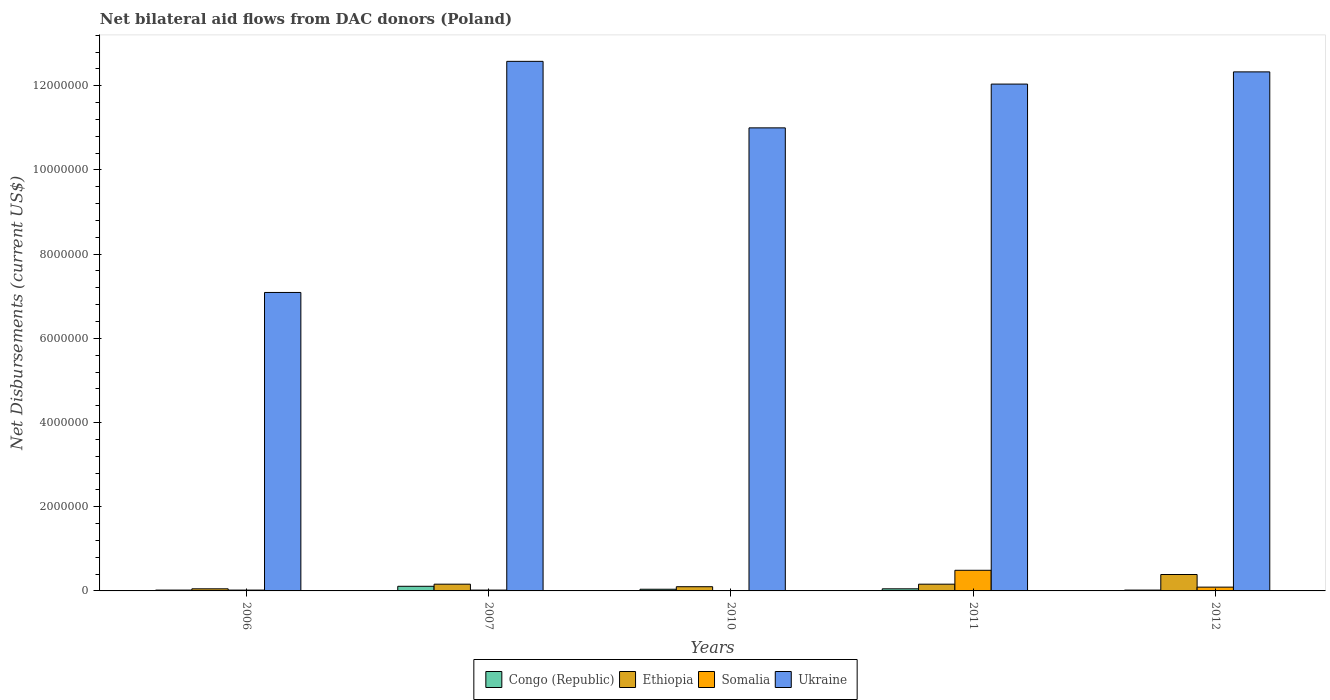How many different coloured bars are there?
Your answer should be very brief. 4. How many groups of bars are there?
Your answer should be very brief. 5. Are the number of bars per tick equal to the number of legend labels?
Keep it short and to the point. Yes. How many bars are there on the 1st tick from the left?
Give a very brief answer. 4. How many bars are there on the 3rd tick from the right?
Provide a short and direct response. 4. What is the label of the 3rd group of bars from the left?
Your answer should be compact. 2010. In how many cases, is the number of bars for a given year not equal to the number of legend labels?
Your response must be concise. 0. What is the net bilateral aid flows in Ethiopia in 2007?
Provide a succinct answer. 1.60e+05. Across all years, what is the maximum net bilateral aid flows in Ethiopia?
Your response must be concise. 3.90e+05. Across all years, what is the minimum net bilateral aid flows in Ethiopia?
Your answer should be very brief. 5.00e+04. In which year was the net bilateral aid flows in Ethiopia minimum?
Your answer should be very brief. 2006. What is the total net bilateral aid flows in Somalia in the graph?
Offer a terse response. 6.30e+05. What is the difference between the net bilateral aid flows in Ukraine in 2010 and the net bilateral aid flows in Congo (Republic) in 2012?
Offer a very short reply. 1.10e+07. What is the average net bilateral aid flows in Somalia per year?
Keep it short and to the point. 1.26e+05. In how many years, is the net bilateral aid flows in Congo (Republic) greater than 7200000 US$?
Your answer should be compact. 0. What is the ratio of the net bilateral aid flows in Congo (Republic) in 2007 to that in 2011?
Ensure brevity in your answer.  2.2. What is the difference between the highest and the lowest net bilateral aid flows in Ethiopia?
Your answer should be very brief. 3.40e+05. What does the 4th bar from the left in 2011 represents?
Your answer should be compact. Ukraine. What does the 1st bar from the right in 2006 represents?
Keep it short and to the point. Ukraine. Is it the case that in every year, the sum of the net bilateral aid flows in Somalia and net bilateral aid flows in Congo (Republic) is greater than the net bilateral aid flows in Ukraine?
Offer a terse response. No. How many bars are there?
Your answer should be very brief. 20. How many years are there in the graph?
Provide a short and direct response. 5. Where does the legend appear in the graph?
Offer a very short reply. Bottom center. What is the title of the graph?
Make the answer very short. Net bilateral aid flows from DAC donors (Poland). What is the label or title of the Y-axis?
Offer a very short reply. Net Disbursements (current US$). What is the Net Disbursements (current US$) in Ethiopia in 2006?
Your response must be concise. 5.00e+04. What is the Net Disbursements (current US$) in Somalia in 2006?
Provide a succinct answer. 2.00e+04. What is the Net Disbursements (current US$) of Ukraine in 2006?
Your response must be concise. 7.09e+06. What is the Net Disbursements (current US$) of Congo (Republic) in 2007?
Keep it short and to the point. 1.10e+05. What is the Net Disbursements (current US$) in Ethiopia in 2007?
Provide a short and direct response. 1.60e+05. What is the Net Disbursements (current US$) in Somalia in 2007?
Your answer should be very brief. 2.00e+04. What is the Net Disbursements (current US$) of Ukraine in 2007?
Your response must be concise. 1.26e+07. What is the Net Disbursements (current US$) in Somalia in 2010?
Keep it short and to the point. 10000. What is the Net Disbursements (current US$) in Ukraine in 2010?
Offer a very short reply. 1.10e+07. What is the Net Disbursements (current US$) of Somalia in 2011?
Your answer should be compact. 4.90e+05. What is the Net Disbursements (current US$) in Ukraine in 2011?
Offer a very short reply. 1.20e+07. What is the Net Disbursements (current US$) of Ukraine in 2012?
Your response must be concise. 1.23e+07. Across all years, what is the maximum Net Disbursements (current US$) of Ukraine?
Your answer should be very brief. 1.26e+07. Across all years, what is the minimum Net Disbursements (current US$) in Congo (Republic)?
Your response must be concise. 2.00e+04. Across all years, what is the minimum Net Disbursements (current US$) in Ethiopia?
Offer a very short reply. 5.00e+04. Across all years, what is the minimum Net Disbursements (current US$) of Somalia?
Provide a short and direct response. 10000. Across all years, what is the minimum Net Disbursements (current US$) of Ukraine?
Your answer should be very brief. 7.09e+06. What is the total Net Disbursements (current US$) of Congo (Republic) in the graph?
Offer a very short reply. 2.40e+05. What is the total Net Disbursements (current US$) of Ethiopia in the graph?
Give a very brief answer. 8.60e+05. What is the total Net Disbursements (current US$) of Somalia in the graph?
Ensure brevity in your answer.  6.30e+05. What is the total Net Disbursements (current US$) of Ukraine in the graph?
Keep it short and to the point. 5.50e+07. What is the difference between the Net Disbursements (current US$) in Congo (Republic) in 2006 and that in 2007?
Make the answer very short. -9.00e+04. What is the difference between the Net Disbursements (current US$) of Ethiopia in 2006 and that in 2007?
Your answer should be compact. -1.10e+05. What is the difference between the Net Disbursements (current US$) of Ukraine in 2006 and that in 2007?
Give a very brief answer. -5.49e+06. What is the difference between the Net Disbursements (current US$) in Ukraine in 2006 and that in 2010?
Your answer should be compact. -3.91e+06. What is the difference between the Net Disbursements (current US$) in Congo (Republic) in 2006 and that in 2011?
Keep it short and to the point. -3.00e+04. What is the difference between the Net Disbursements (current US$) of Ethiopia in 2006 and that in 2011?
Your answer should be very brief. -1.10e+05. What is the difference between the Net Disbursements (current US$) of Somalia in 2006 and that in 2011?
Make the answer very short. -4.70e+05. What is the difference between the Net Disbursements (current US$) in Ukraine in 2006 and that in 2011?
Provide a succinct answer. -4.95e+06. What is the difference between the Net Disbursements (current US$) of Ethiopia in 2006 and that in 2012?
Provide a succinct answer. -3.40e+05. What is the difference between the Net Disbursements (current US$) of Ukraine in 2006 and that in 2012?
Your response must be concise. -5.24e+06. What is the difference between the Net Disbursements (current US$) of Congo (Republic) in 2007 and that in 2010?
Your response must be concise. 7.00e+04. What is the difference between the Net Disbursements (current US$) of Ethiopia in 2007 and that in 2010?
Ensure brevity in your answer.  6.00e+04. What is the difference between the Net Disbursements (current US$) in Somalia in 2007 and that in 2010?
Your answer should be compact. 10000. What is the difference between the Net Disbursements (current US$) in Ukraine in 2007 and that in 2010?
Offer a terse response. 1.58e+06. What is the difference between the Net Disbursements (current US$) of Ethiopia in 2007 and that in 2011?
Your response must be concise. 0. What is the difference between the Net Disbursements (current US$) of Somalia in 2007 and that in 2011?
Ensure brevity in your answer.  -4.70e+05. What is the difference between the Net Disbursements (current US$) of Ukraine in 2007 and that in 2011?
Ensure brevity in your answer.  5.40e+05. What is the difference between the Net Disbursements (current US$) in Congo (Republic) in 2007 and that in 2012?
Give a very brief answer. 9.00e+04. What is the difference between the Net Disbursements (current US$) in Somalia in 2007 and that in 2012?
Your response must be concise. -7.00e+04. What is the difference between the Net Disbursements (current US$) in Ethiopia in 2010 and that in 2011?
Give a very brief answer. -6.00e+04. What is the difference between the Net Disbursements (current US$) in Somalia in 2010 and that in 2011?
Keep it short and to the point. -4.80e+05. What is the difference between the Net Disbursements (current US$) in Ukraine in 2010 and that in 2011?
Ensure brevity in your answer.  -1.04e+06. What is the difference between the Net Disbursements (current US$) in Congo (Republic) in 2010 and that in 2012?
Ensure brevity in your answer.  2.00e+04. What is the difference between the Net Disbursements (current US$) of Somalia in 2010 and that in 2012?
Your answer should be very brief. -8.00e+04. What is the difference between the Net Disbursements (current US$) of Ukraine in 2010 and that in 2012?
Make the answer very short. -1.33e+06. What is the difference between the Net Disbursements (current US$) in Ethiopia in 2011 and that in 2012?
Keep it short and to the point. -2.30e+05. What is the difference between the Net Disbursements (current US$) in Ukraine in 2011 and that in 2012?
Your answer should be very brief. -2.90e+05. What is the difference between the Net Disbursements (current US$) in Congo (Republic) in 2006 and the Net Disbursements (current US$) in Ethiopia in 2007?
Your response must be concise. -1.40e+05. What is the difference between the Net Disbursements (current US$) of Congo (Republic) in 2006 and the Net Disbursements (current US$) of Ukraine in 2007?
Make the answer very short. -1.26e+07. What is the difference between the Net Disbursements (current US$) of Ethiopia in 2006 and the Net Disbursements (current US$) of Somalia in 2007?
Provide a short and direct response. 3.00e+04. What is the difference between the Net Disbursements (current US$) in Ethiopia in 2006 and the Net Disbursements (current US$) in Ukraine in 2007?
Your answer should be compact. -1.25e+07. What is the difference between the Net Disbursements (current US$) in Somalia in 2006 and the Net Disbursements (current US$) in Ukraine in 2007?
Your response must be concise. -1.26e+07. What is the difference between the Net Disbursements (current US$) in Congo (Republic) in 2006 and the Net Disbursements (current US$) in Ethiopia in 2010?
Offer a terse response. -8.00e+04. What is the difference between the Net Disbursements (current US$) in Congo (Republic) in 2006 and the Net Disbursements (current US$) in Somalia in 2010?
Make the answer very short. 10000. What is the difference between the Net Disbursements (current US$) in Congo (Republic) in 2006 and the Net Disbursements (current US$) in Ukraine in 2010?
Your answer should be very brief. -1.10e+07. What is the difference between the Net Disbursements (current US$) of Ethiopia in 2006 and the Net Disbursements (current US$) of Ukraine in 2010?
Provide a succinct answer. -1.10e+07. What is the difference between the Net Disbursements (current US$) in Somalia in 2006 and the Net Disbursements (current US$) in Ukraine in 2010?
Your response must be concise. -1.10e+07. What is the difference between the Net Disbursements (current US$) in Congo (Republic) in 2006 and the Net Disbursements (current US$) in Somalia in 2011?
Ensure brevity in your answer.  -4.70e+05. What is the difference between the Net Disbursements (current US$) of Congo (Republic) in 2006 and the Net Disbursements (current US$) of Ukraine in 2011?
Keep it short and to the point. -1.20e+07. What is the difference between the Net Disbursements (current US$) in Ethiopia in 2006 and the Net Disbursements (current US$) in Somalia in 2011?
Provide a succinct answer. -4.40e+05. What is the difference between the Net Disbursements (current US$) in Ethiopia in 2006 and the Net Disbursements (current US$) in Ukraine in 2011?
Give a very brief answer. -1.20e+07. What is the difference between the Net Disbursements (current US$) in Somalia in 2006 and the Net Disbursements (current US$) in Ukraine in 2011?
Provide a succinct answer. -1.20e+07. What is the difference between the Net Disbursements (current US$) of Congo (Republic) in 2006 and the Net Disbursements (current US$) of Ethiopia in 2012?
Keep it short and to the point. -3.70e+05. What is the difference between the Net Disbursements (current US$) of Congo (Republic) in 2006 and the Net Disbursements (current US$) of Ukraine in 2012?
Offer a terse response. -1.23e+07. What is the difference between the Net Disbursements (current US$) in Ethiopia in 2006 and the Net Disbursements (current US$) in Ukraine in 2012?
Offer a very short reply. -1.23e+07. What is the difference between the Net Disbursements (current US$) in Somalia in 2006 and the Net Disbursements (current US$) in Ukraine in 2012?
Offer a terse response. -1.23e+07. What is the difference between the Net Disbursements (current US$) in Congo (Republic) in 2007 and the Net Disbursements (current US$) in Somalia in 2010?
Give a very brief answer. 1.00e+05. What is the difference between the Net Disbursements (current US$) in Congo (Republic) in 2007 and the Net Disbursements (current US$) in Ukraine in 2010?
Ensure brevity in your answer.  -1.09e+07. What is the difference between the Net Disbursements (current US$) of Ethiopia in 2007 and the Net Disbursements (current US$) of Ukraine in 2010?
Provide a succinct answer. -1.08e+07. What is the difference between the Net Disbursements (current US$) in Somalia in 2007 and the Net Disbursements (current US$) in Ukraine in 2010?
Provide a succinct answer. -1.10e+07. What is the difference between the Net Disbursements (current US$) of Congo (Republic) in 2007 and the Net Disbursements (current US$) of Ethiopia in 2011?
Your answer should be compact. -5.00e+04. What is the difference between the Net Disbursements (current US$) in Congo (Republic) in 2007 and the Net Disbursements (current US$) in Somalia in 2011?
Give a very brief answer. -3.80e+05. What is the difference between the Net Disbursements (current US$) of Congo (Republic) in 2007 and the Net Disbursements (current US$) of Ukraine in 2011?
Your response must be concise. -1.19e+07. What is the difference between the Net Disbursements (current US$) of Ethiopia in 2007 and the Net Disbursements (current US$) of Somalia in 2011?
Your answer should be compact. -3.30e+05. What is the difference between the Net Disbursements (current US$) in Ethiopia in 2007 and the Net Disbursements (current US$) in Ukraine in 2011?
Give a very brief answer. -1.19e+07. What is the difference between the Net Disbursements (current US$) in Somalia in 2007 and the Net Disbursements (current US$) in Ukraine in 2011?
Your answer should be very brief. -1.20e+07. What is the difference between the Net Disbursements (current US$) in Congo (Republic) in 2007 and the Net Disbursements (current US$) in Ethiopia in 2012?
Your response must be concise. -2.80e+05. What is the difference between the Net Disbursements (current US$) of Congo (Republic) in 2007 and the Net Disbursements (current US$) of Somalia in 2012?
Ensure brevity in your answer.  2.00e+04. What is the difference between the Net Disbursements (current US$) of Congo (Republic) in 2007 and the Net Disbursements (current US$) of Ukraine in 2012?
Your answer should be compact. -1.22e+07. What is the difference between the Net Disbursements (current US$) of Ethiopia in 2007 and the Net Disbursements (current US$) of Ukraine in 2012?
Your answer should be very brief. -1.22e+07. What is the difference between the Net Disbursements (current US$) in Somalia in 2007 and the Net Disbursements (current US$) in Ukraine in 2012?
Ensure brevity in your answer.  -1.23e+07. What is the difference between the Net Disbursements (current US$) in Congo (Republic) in 2010 and the Net Disbursements (current US$) in Somalia in 2011?
Keep it short and to the point. -4.50e+05. What is the difference between the Net Disbursements (current US$) of Congo (Republic) in 2010 and the Net Disbursements (current US$) of Ukraine in 2011?
Make the answer very short. -1.20e+07. What is the difference between the Net Disbursements (current US$) of Ethiopia in 2010 and the Net Disbursements (current US$) of Somalia in 2011?
Provide a succinct answer. -3.90e+05. What is the difference between the Net Disbursements (current US$) of Ethiopia in 2010 and the Net Disbursements (current US$) of Ukraine in 2011?
Make the answer very short. -1.19e+07. What is the difference between the Net Disbursements (current US$) of Somalia in 2010 and the Net Disbursements (current US$) of Ukraine in 2011?
Your answer should be very brief. -1.20e+07. What is the difference between the Net Disbursements (current US$) of Congo (Republic) in 2010 and the Net Disbursements (current US$) of Ethiopia in 2012?
Give a very brief answer. -3.50e+05. What is the difference between the Net Disbursements (current US$) in Congo (Republic) in 2010 and the Net Disbursements (current US$) in Somalia in 2012?
Your answer should be very brief. -5.00e+04. What is the difference between the Net Disbursements (current US$) of Congo (Republic) in 2010 and the Net Disbursements (current US$) of Ukraine in 2012?
Your answer should be compact. -1.23e+07. What is the difference between the Net Disbursements (current US$) in Ethiopia in 2010 and the Net Disbursements (current US$) in Ukraine in 2012?
Your answer should be very brief. -1.22e+07. What is the difference between the Net Disbursements (current US$) in Somalia in 2010 and the Net Disbursements (current US$) in Ukraine in 2012?
Keep it short and to the point. -1.23e+07. What is the difference between the Net Disbursements (current US$) of Congo (Republic) in 2011 and the Net Disbursements (current US$) of Somalia in 2012?
Your answer should be very brief. -4.00e+04. What is the difference between the Net Disbursements (current US$) of Congo (Republic) in 2011 and the Net Disbursements (current US$) of Ukraine in 2012?
Give a very brief answer. -1.23e+07. What is the difference between the Net Disbursements (current US$) in Ethiopia in 2011 and the Net Disbursements (current US$) in Ukraine in 2012?
Your answer should be very brief. -1.22e+07. What is the difference between the Net Disbursements (current US$) in Somalia in 2011 and the Net Disbursements (current US$) in Ukraine in 2012?
Keep it short and to the point. -1.18e+07. What is the average Net Disbursements (current US$) of Congo (Republic) per year?
Ensure brevity in your answer.  4.80e+04. What is the average Net Disbursements (current US$) in Ethiopia per year?
Offer a very short reply. 1.72e+05. What is the average Net Disbursements (current US$) in Somalia per year?
Offer a very short reply. 1.26e+05. What is the average Net Disbursements (current US$) in Ukraine per year?
Keep it short and to the point. 1.10e+07. In the year 2006, what is the difference between the Net Disbursements (current US$) of Congo (Republic) and Net Disbursements (current US$) of Ethiopia?
Ensure brevity in your answer.  -3.00e+04. In the year 2006, what is the difference between the Net Disbursements (current US$) in Congo (Republic) and Net Disbursements (current US$) in Somalia?
Your answer should be compact. 0. In the year 2006, what is the difference between the Net Disbursements (current US$) in Congo (Republic) and Net Disbursements (current US$) in Ukraine?
Make the answer very short. -7.07e+06. In the year 2006, what is the difference between the Net Disbursements (current US$) in Ethiopia and Net Disbursements (current US$) in Ukraine?
Give a very brief answer. -7.04e+06. In the year 2006, what is the difference between the Net Disbursements (current US$) of Somalia and Net Disbursements (current US$) of Ukraine?
Provide a short and direct response. -7.07e+06. In the year 2007, what is the difference between the Net Disbursements (current US$) in Congo (Republic) and Net Disbursements (current US$) in Ethiopia?
Your answer should be very brief. -5.00e+04. In the year 2007, what is the difference between the Net Disbursements (current US$) of Congo (Republic) and Net Disbursements (current US$) of Somalia?
Provide a short and direct response. 9.00e+04. In the year 2007, what is the difference between the Net Disbursements (current US$) of Congo (Republic) and Net Disbursements (current US$) of Ukraine?
Your response must be concise. -1.25e+07. In the year 2007, what is the difference between the Net Disbursements (current US$) in Ethiopia and Net Disbursements (current US$) in Somalia?
Your response must be concise. 1.40e+05. In the year 2007, what is the difference between the Net Disbursements (current US$) of Ethiopia and Net Disbursements (current US$) of Ukraine?
Offer a terse response. -1.24e+07. In the year 2007, what is the difference between the Net Disbursements (current US$) of Somalia and Net Disbursements (current US$) of Ukraine?
Make the answer very short. -1.26e+07. In the year 2010, what is the difference between the Net Disbursements (current US$) in Congo (Republic) and Net Disbursements (current US$) in Somalia?
Give a very brief answer. 3.00e+04. In the year 2010, what is the difference between the Net Disbursements (current US$) of Congo (Republic) and Net Disbursements (current US$) of Ukraine?
Make the answer very short. -1.10e+07. In the year 2010, what is the difference between the Net Disbursements (current US$) in Ethiopia and Net Disbursements (current US$) in Somalia?
Your answer should be compact. 9.00e+04. In the year 2010, what is the difference between the Net Disbursements (current US$) of Ethiopia and Net Disbursements (current US$) of Ukraine?
Provide a short and direct response. -1.09e+07. In the year 2010, what is the difference between the Net Disbursements (current US$) in Somalia and Net Disbursements (current US$) in Ukraine?
Your answer should be very brief. -1.10e+07. In the year 2011, what is the difference between the Net Disbursements (current US$) in Congo (Republic) and Net Disbursements (current US$) in Somalia?
Your answer should be compact. -4.40e+05. In the year 2011, what is the difference between the Net Disbursements (current US$) in Congo (Republic) and Net Disbursements (current US$) in Ukraine?
Your answer should be compact. -1.20e+07. In the year 2011, what is the difference between the Net Disbursements (current US$) of Ethiopia and Net Disbursements (current US$) of Somalia?
Your answer should be compact. -3.30e+05. In the year 2011, what is the difference between the Net Disbursements (current US$) in Ethiopia and Net Disbursements (current US$) in Ukraine?
Give a very brief answer. -1.19e+07. In the year 2011, what is the difference between the Net Disbursements (current US$) of Somalia and Net Disbursements (current US$) of Ukraine?
Your answer should be compact. -1.16e+07. In the year 2012, what is the difference between the Net Disbursements (current US$) of Congo (Republic) and Net Disbursements (current US$) of Ethiopia?
Offer a terse response. -3.70e+05. In the year 2012, what is the difference between the Net Disbursements (current US$) in Congo (Republic) and Net Disbursements (current US$) in Somalia?
Your answer should be very brief. -7.00e+04. In the year 2012, what is the difference between the Net Disbursements (current US$) in Congo (Republic) and Net Disbursements (current US$) in Ukraine?
Provide a short and direct response. -1.23e+07. In the year 2012, what is the difference between the Net Disbursements (current US$) in Ethiopia and Net Disbursements (current US$) in Ukraine?
Make the answer very short. -1.19e+07. In the year 2012, what is the difference between the Net Disbursements (current US$) of Somalia and Net Disbursements (current US$) of Ukraine?
Give a very brief answer. -1.22e+07. What is the ratio of the Net Disbursements (current US$) of Congo (Republic) in 2006 to that in 2007?
Offer a terse response. 0.18. What is the ratio of the Net Disbursements (current US$) in Ethiopia in 2006 to that in 2007?
Provide a short and direct response. 0.31. What is the ratio of the Net Disbursements (current US$) in Ukraine in 2006 to that in 2007?
Offer a terse response. 0.56. What is the ratio of the Net Disbursements (current US$) of Ethiopia in 2006 to that in 2010?
Your answer should be compact. 0.5. What is the ratio of the Net Disbursements (current US$) of Somalia in 2006 to that in 2010?
Offer a very short reply. 2. What is the ratio of the Net Disbursements (current US$) in Ukraine in 2006 to that in 2010?
Your answer should be compact. 0.64. What is the ratio of the Net Disbursements (current US$) in Congo (Republic) in 2006 to that in 2011?
Give a very brief answer. 0.4. What is the ratio of the Net Disbursements (current US$) of Ethiopia in 2006 to that in 2011?
Make the answer very short. 0.31. What is the ratio of the Net Disbursements (current US$) in Somalia in 2006 to that in 2011?
Make the answer very short. 0.04. What is the ratio of the Net Disbursements (current US$) in Ukraine in 2006 to that in 2011?
Keep it short and to the point. 0.59. What is the ratio of the Net Disbursements (current US$) of Ethiopia in 2006 to that in 2012?
Your answer should be compact. 0.13. What is the ratio of the Net Disbursements (current US$) of Somalia in 2006 to that in 2012?
Offer a terse response. 0.22. What is the ratio of the Net Disbursements (current US$) of Ukraine in 2006 to that in 2012?
Your answer should be compact. 0.57. What is the ratio of the Net Disbursements (current US$) of Congo (Republic) in 2007 to that in 2010?
Keep it short and to the point. 2.75. What is the ratio of the Net Disbursements (current US$) in Somalia in 2007 to that in 2010?
Give a very brief answer. 2. What is the ratio of the Net Disbursements (current US$) in Ukraine in 2007 to that in 2010?
Give a very brief answer. 1.14. What is the ratio of the Net Disbursements (current US$) of Congo (Republic) in 2007 to that in 2011?
Provide a short and direct response. 2.2. What is the ratio of the Net Disbursements (current US$) of Ethiopia in 2007 to that in 2011?
Offer a very short reply. 1. What is the ratio of the Net Disbursements (current US$) in Somalia in 2007 to that in 2011?
Provide a short and direct response. 0.04. What is the ratio of the Net Disbursements (current US$) in Ukraine in 2007 to that in 2011?
Your response must be concise. 1.04. What is the ratio of the Net Disbursements (current US$) of Ethiopia in 2007 to that in 2012?
Make the answer very short. 0.41. What is the ratio of the Net Disbursements (current US$) of Somalia in 2007 to that in 2012?
Your response must be concise. 0.22. What is the ratio of the Net Disbursements (current US$) of Ukraine in 2007 to that in 2012?
Give a very brief answer. 1.02. What is the ratio of the Net Disbursements (current US$) in Ethiopia in 2010 to that in 2011?
Provide a short and direct response. 0.62. What is the ratio of the Net Disbursements (current US$) of Somalia in 2010 to that in 2011?
Offer a very short reply. 0.02. What is the ratio of the Net Disbursements (current US$) in Ukraine in 2010 to that in 2011?
Keep it short and to the point. 0.91. What is the ratio of the Net Disbursements (current US$) in Congo (Republic) in 2010 to that in 2012?
Make the answer very short. 2. What is the ratio of the Net Disbursements (current US$) of Ethiopia in 2010 to that in 2012?
Ensure brevity in your answer.  0.26. What is the ratio of the Net Disbursements (current US$) of Ukraine in 2010 to that in 2012?
Ensure brevity in your answer.  0.89. What is the ratio of the Net Disbursements (current US$) of Congo (Republic) in 2011 to that in 2012?
Offer a terse response. 2.5. What is the ratio of the Net Disbursements (current US$) of Ethiopia in 2011 to that in 2012?
Provide a succinct answer. 0.41. What is the ratio of the Net Disbursements (current US$) in Somalia in 2011 to that in 2012?
Your answer should be very brief. 5.44. What is the ratio of the Net Disbursements (current US$) in Ukraine in 2011 to that in 2012?
Provide a succinct answer. 0.98. What is the difference between the highest and the second highest Net Disbursements (current US$) of Congo (Republic)?
Your answer should be very brief. 6.00e+04. What is the difference between the highest and the second highest Net Disbursements (current US$) of Ethiopia?
Provide a succinct answer. 2.30e+05. What is the difference between the highest and the second highest Net Disbursements (current US$) of Somalia?
Provide a short and direct response. 4.00e+05. What is the difference between the highest and the lowest Net Disbursements (current US$) in Somalia?
Your answer should be very brief. 4.80e+05. What is the difference between the highest and the lowest Net Disbursements (current US$) in Ukraine?
Your response must be concise. 5.49e+06. 